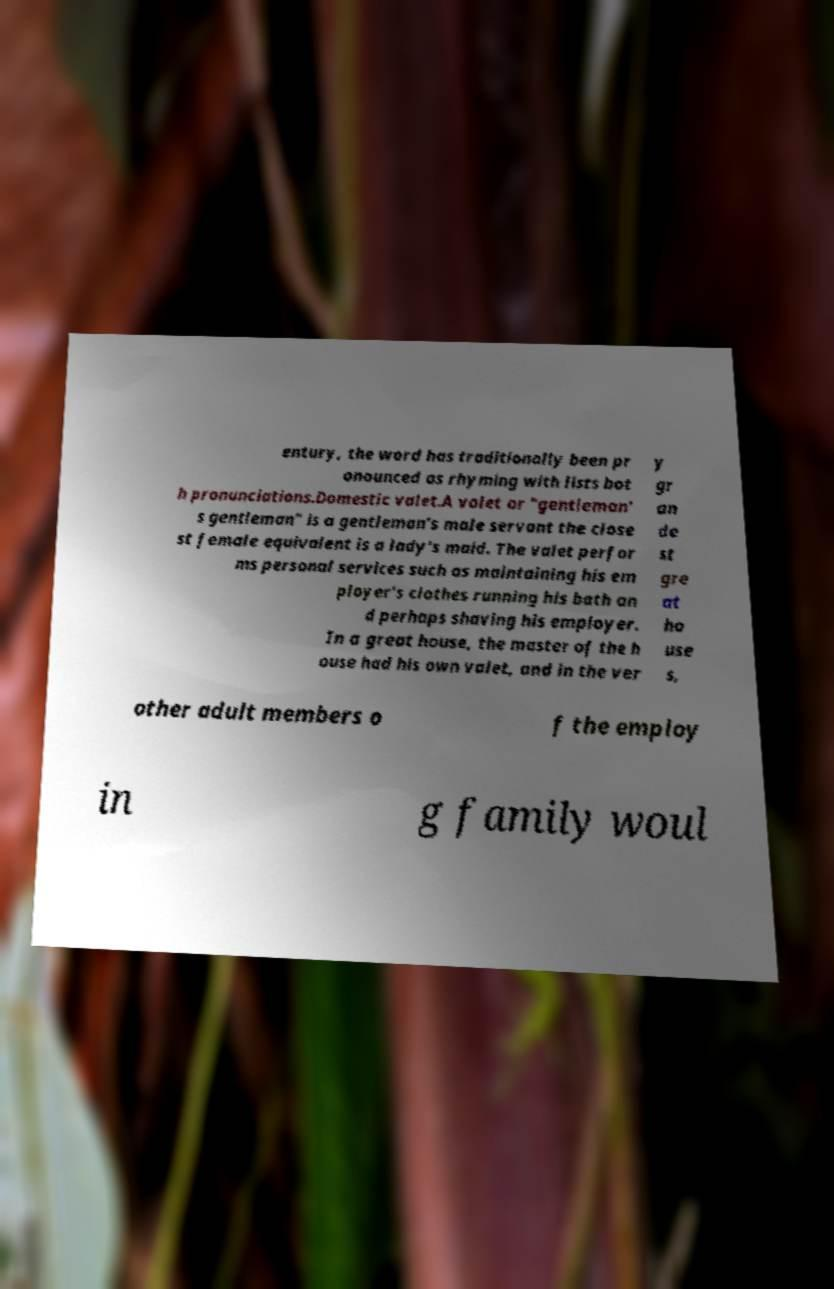Can you read and provide the text displayed in the image?This photo seems to have some interesting text. Can you extract and type it out for me? entury, the word has traditionally been pr onounced as rhyming with lists bot h pronunciations.Domestic valet.A valet or "gentleman' s gentleman" is a gentleman's male servant the close st female equivalent is a lady's maid. The valet perfor ms personal services such as maintaining his em ployer's clothes running his bath an d perhaps shaving his employer. In a great house, the master of the h ouse had his own valet, and in the ver y gr an de st gre at ho use s, other adult members o f the employ in g family woul 